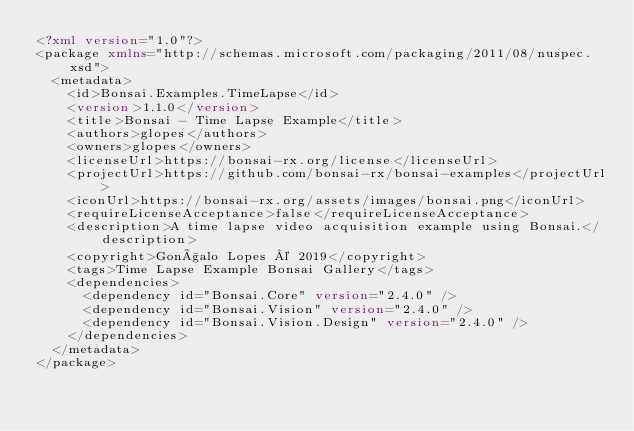Convert code to text. <code><loc_0><loc_0><loc_500><loc_500><_XML_><?xml version="1.0"?>
<package xmlns="http://schemas.microsoft.com/packaging/2011/08/nuspec.xsd">
  <metadata>
    <id>Bonsai.Examples.TimeLapse</id>
    <version>1.1.0</version>
    <title>Bonsai - Time Lapse Example</title>
    <authors>glopes</authors>
    <owners>glopes</owners>
    <licenseUrl>https://bonsai-rx.org/license</licenseUrl>
    <projectUrl>https://github.com/bonsai-rx/bonsai-examples</projectUrl>
    <iconUrl>https://bonsai-rx.org/assets/images/bonsai.png</iconUrl>
    <requireLicenseAcceptance>false</requireLicenseAcceptance>
    <description>A time lapse video acquisition example using Bonsai.</description>
    <copyright>Gonçalo Lopes © 2019</copyright>
    <tags>Time Lapse Example Bonsai Gallery</tags>
    <dependencies>
      <dependency id="Bonsai.Core" version="2.4.0" />
      <dependency id="Bonsai.Vision" version="2.4.0" />
      <dependency id="Bonsai.Vision.Design" version="2.4.0" />
    </dependencies>
  </metadata>
</package></code> 